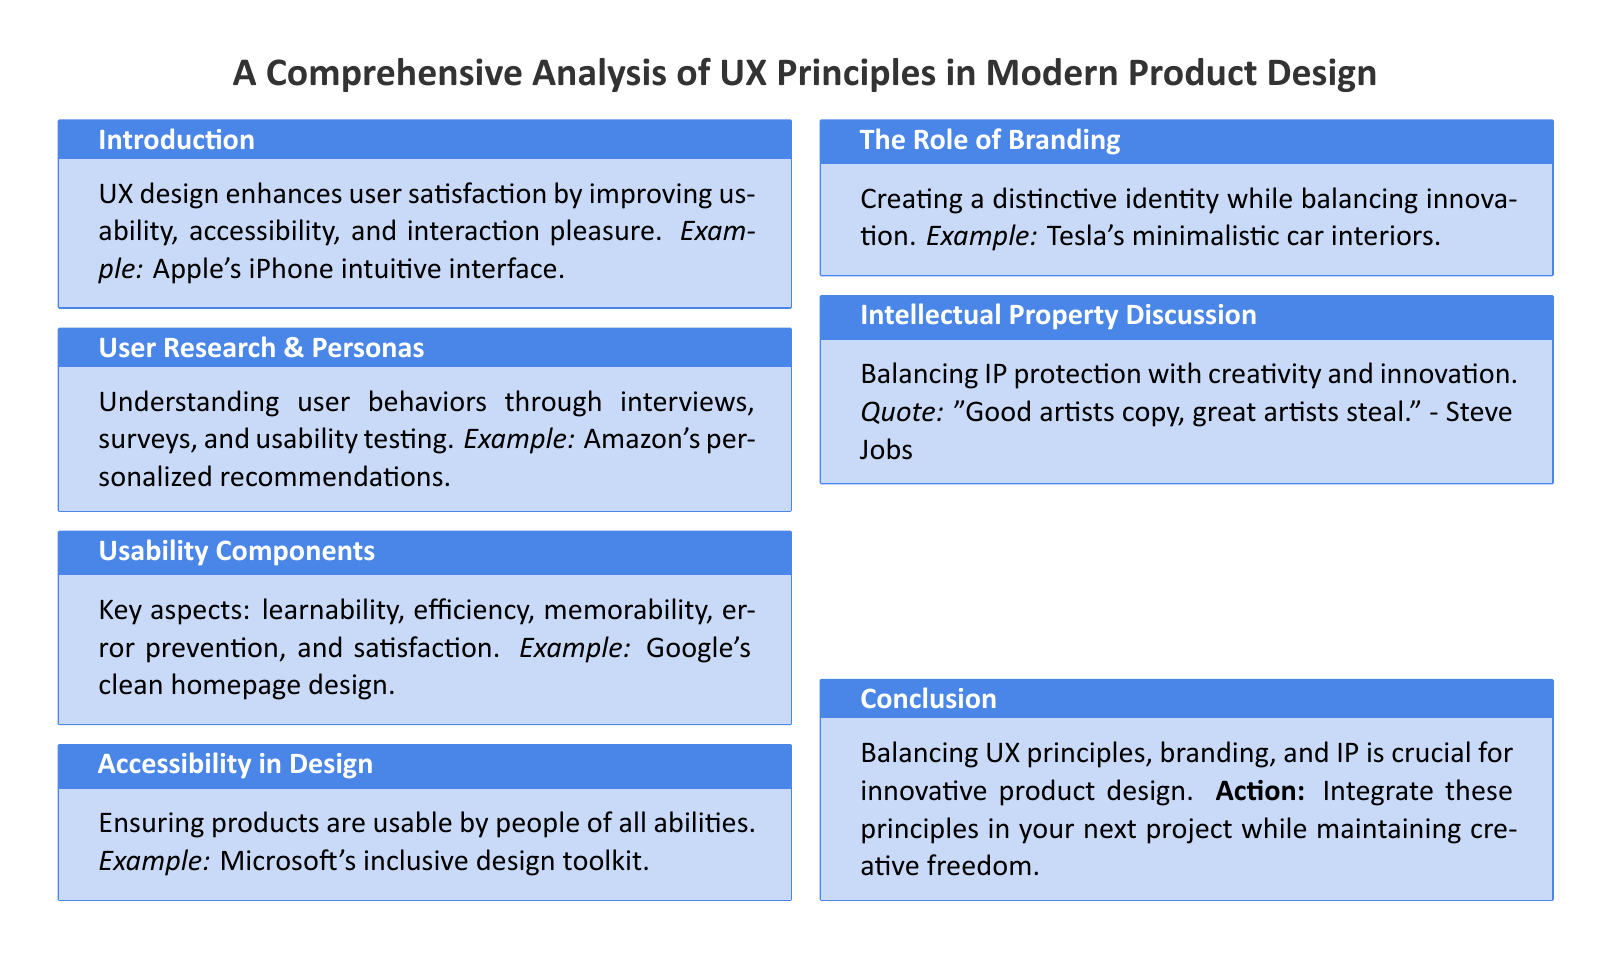What is the role of UX design? UX design enhances user satisfaction by improving usability, accessibility, and interaction pleasure.
Answer: Enhances user satisfaction What example is given for user research? The document provides an example related to understanding user behaviors and uses Amazon's approach.
Answer: Amazon's personalized recommendations What are the key aspects of usability components? The document lists important usability aspects that need to be considered in product design.
Answer: Learnability, efficiency, memorability, error prevention, and satisfaction Who created a toolkit focused on inclusive design? The document mentions a company associated with ensuring products are usable by people of all abilities.
Answer: Microsoft What is the quote attributed to Steve Jobs about creativity? The document includes a quote related to the balance between creativity and imitation in product design.
Answer: "Good artists copy, great artists steal." What is a crucial action mentioned in the conclusion? The conclusion suggests an important step that designers should take in their next project.
Answer: Integrate these principles in your next project What is the focus of the section on the role of branding? This section emphasizes the importance of creating a product identity while maintaining a specific creative approach.
Answer: Distinctive identity while balancing innovation How many sections are in the document? Counting the sections presented in the document provides insight into its structure.
Answer: Six 